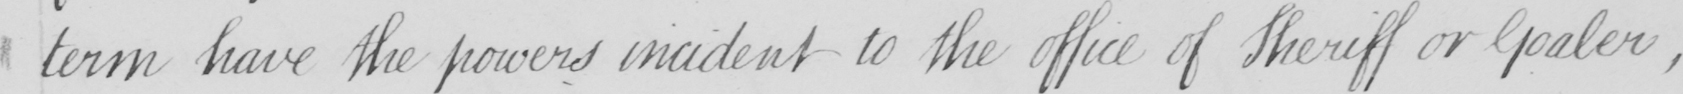Can you read and transcribe this handwriting? term have the powers incident to the office of Sheriff or Goaler  , 